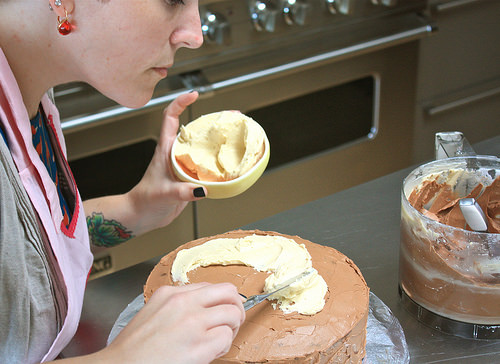<image>
Is there a cake under the plate? No. The cake is not positioned under the plate. The vertical relationship between these objects is different. Is the bowl in front of the woman? Yes. The bowl is positioned in front of the woman, appearing closer to the camera viewpoint. 